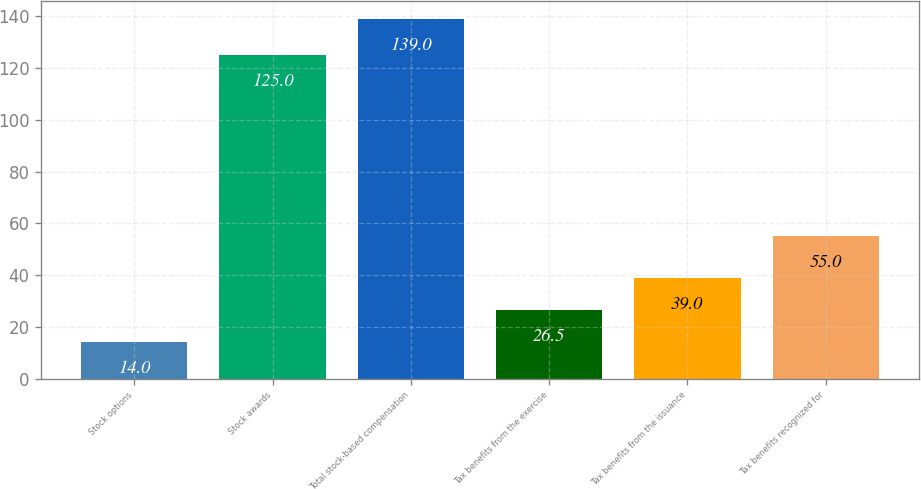Convert chart. <chart><loc_0><loc_0><loc_500><loc_500><bar_chart><fcel>Stock options<fcel>Stock awards<fcel>Total stock-based compensation<fcel>Tax benefits from the exercise<fcel>Tax benefits from the issuance<fcel>Tax benefits recognized for<nl><fcel>14<fcel>125<fcel>139<fcel>26.5<fcel>39<fcel>55<nl></chart> 